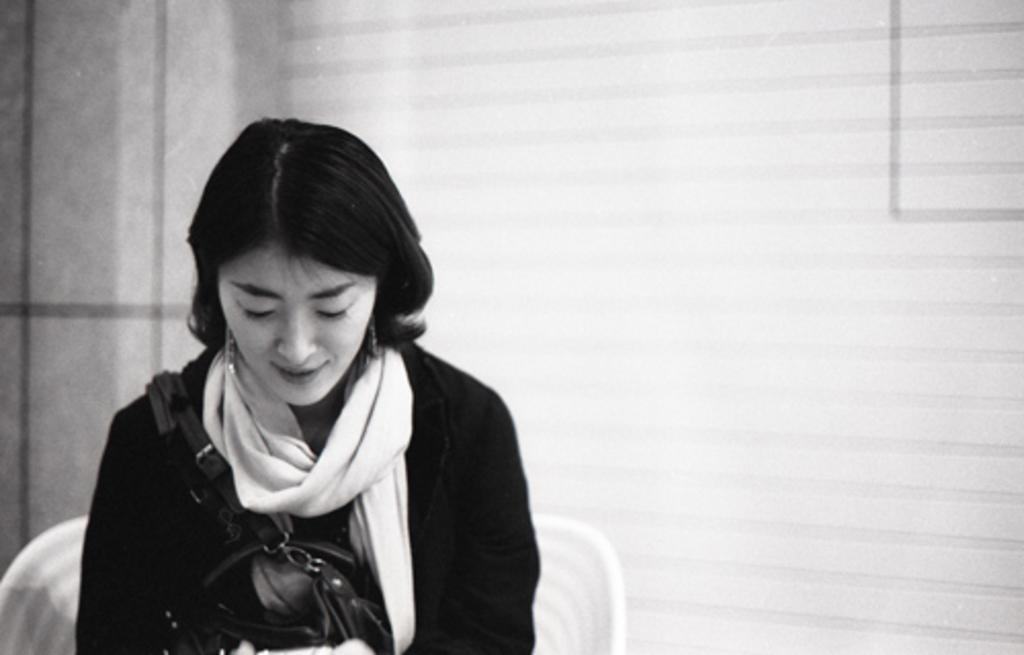Can you describe this image briefly? In the foreground I can see a woman is sitting on the chair. In the background I can see a wall. This image is taken may be in a room. 